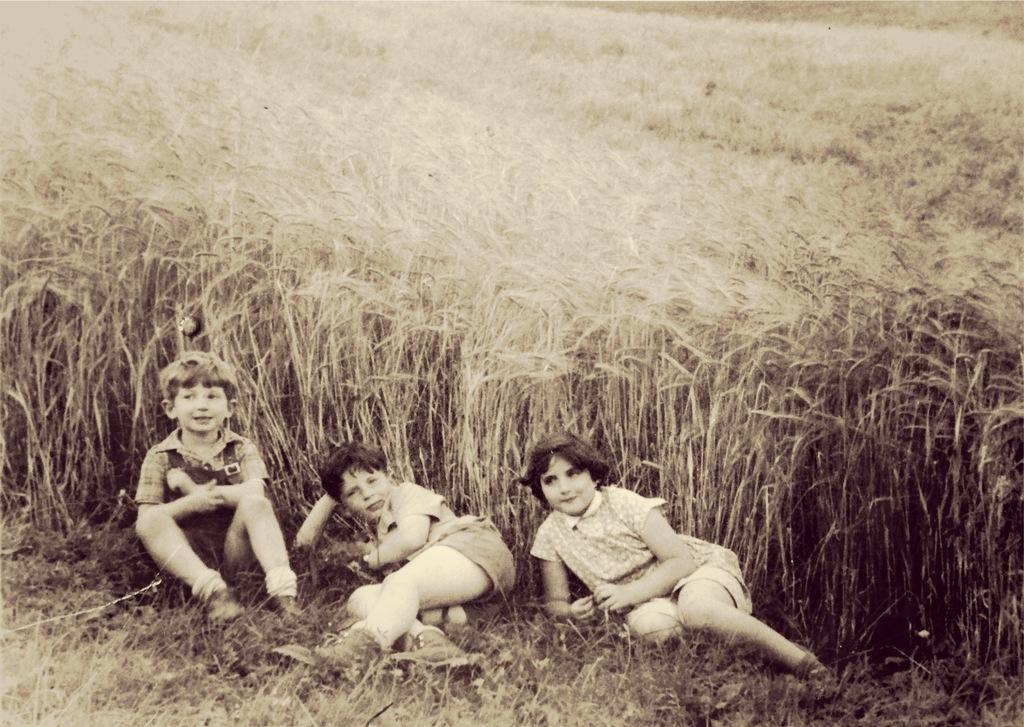What type of living organisms can be seen in the image? Plants can be seen in the image. What else is present in the image besides plants? There are children sitting in the image. What type of notebook is being used by the children in the image? There is no notebook present in the image; the children are simply sitting. Is there a crib visible in the image? No, there is no crib present in the image. 